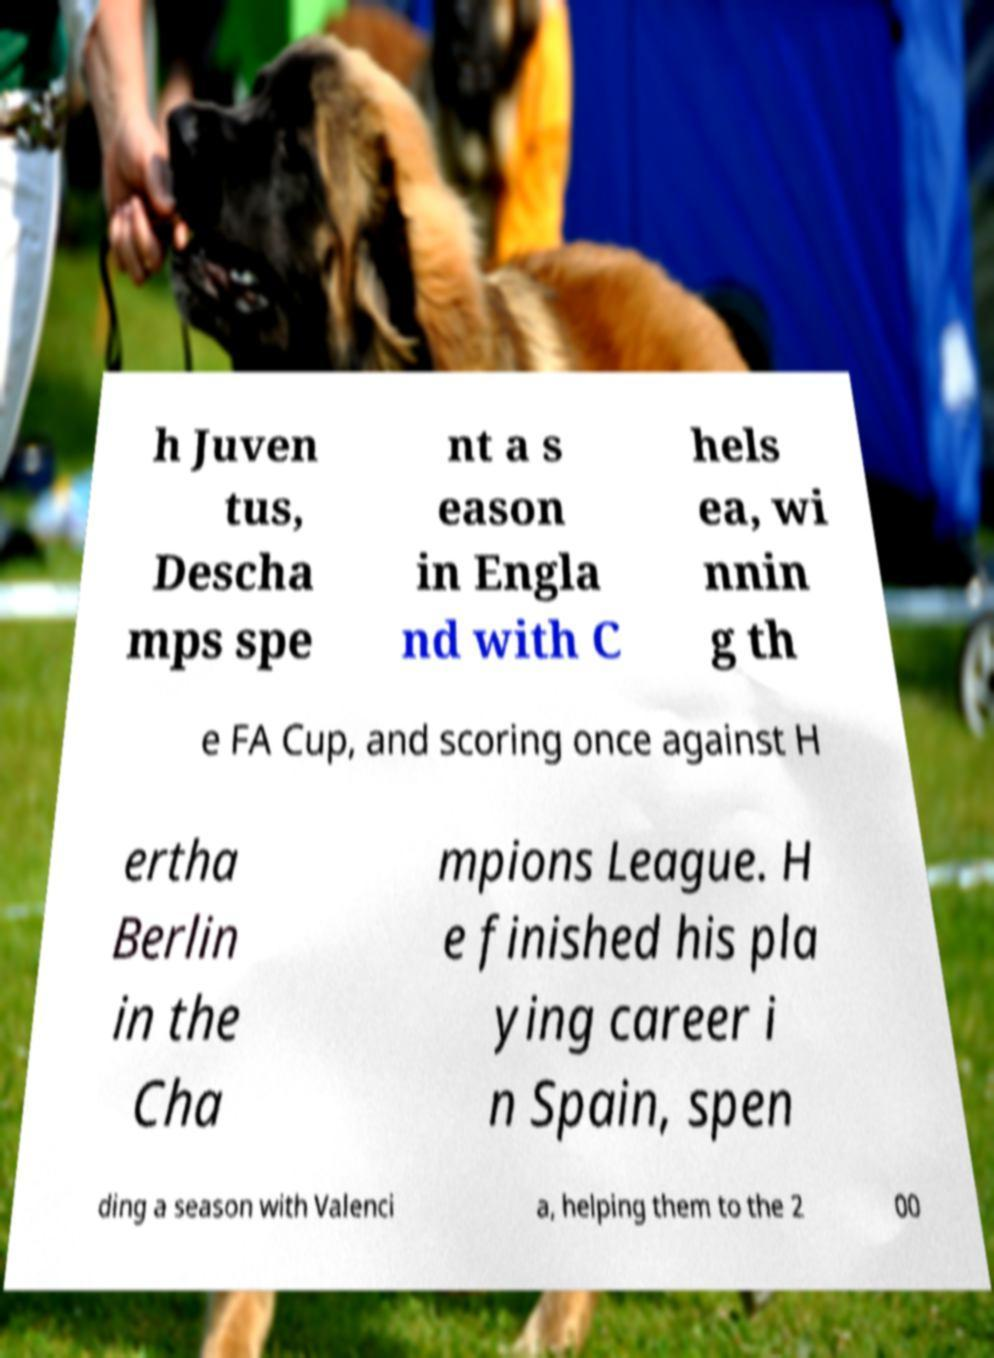Could you assist in decoding the text presented in this image and type it out clearly? h Juven tus, Descha mps spe nt a s eason in Engla nd with C hels ea, wi nnin g th e FA Cup, and scoring once against H ertha Berlin in the Cha mpions League. H e finished his pla ying career i n Spain, spen ding a season with Valenci a, helping them to the 2 00 